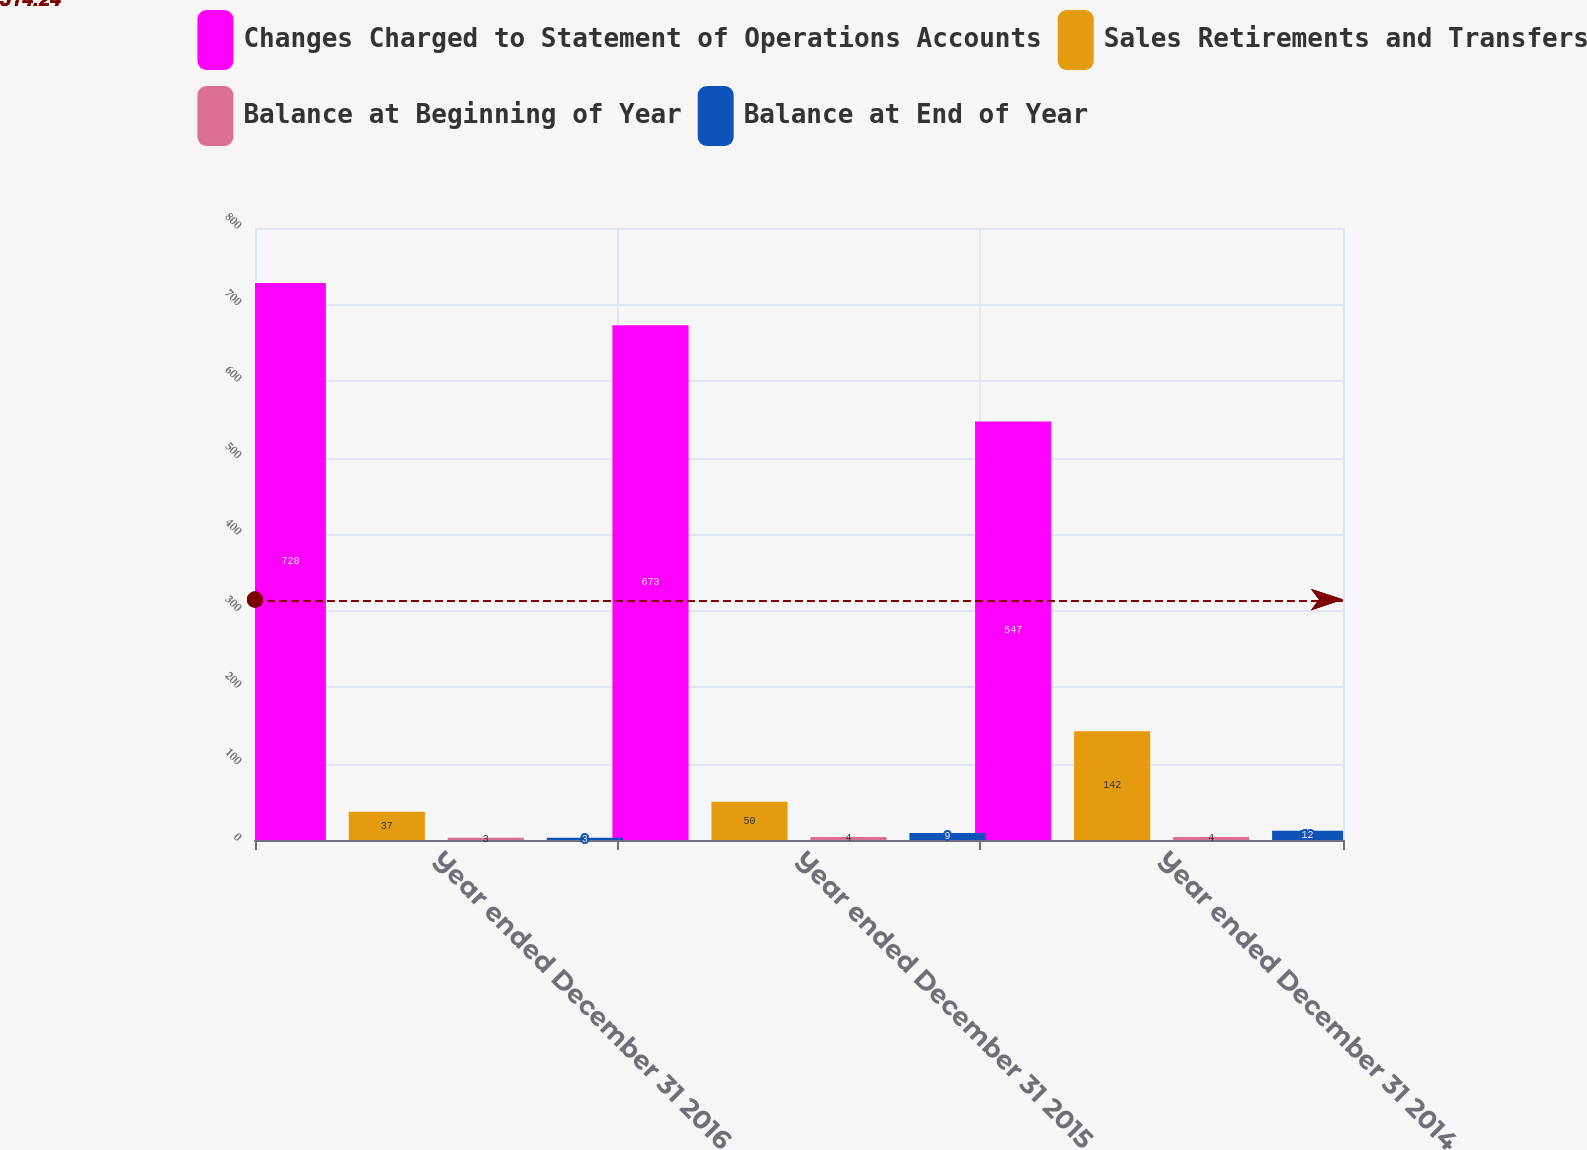<chart> <loc_0><loc_0><loc_500><loc_500><stacked_bar_chart><ecel><fcel>Year ended December 31 2016<fcel>Year ended December 31 2015<fcel>Year ended December 31 2014<nl><fcel>Changes Charged to Statement of Operations Accounts<fcel>728<fcel>673<fcel>547<nl><fcel>Sales Retirements and Transfers<fcel>37<fcel>50<fcel>142<nl><fcel>Balance at Beginning of Year<fcel>3<fcel>4<fcel>4<nl><fcel>Balance at End of Year<fcel>3<fcel>9<fcel>12<nl></chart> 